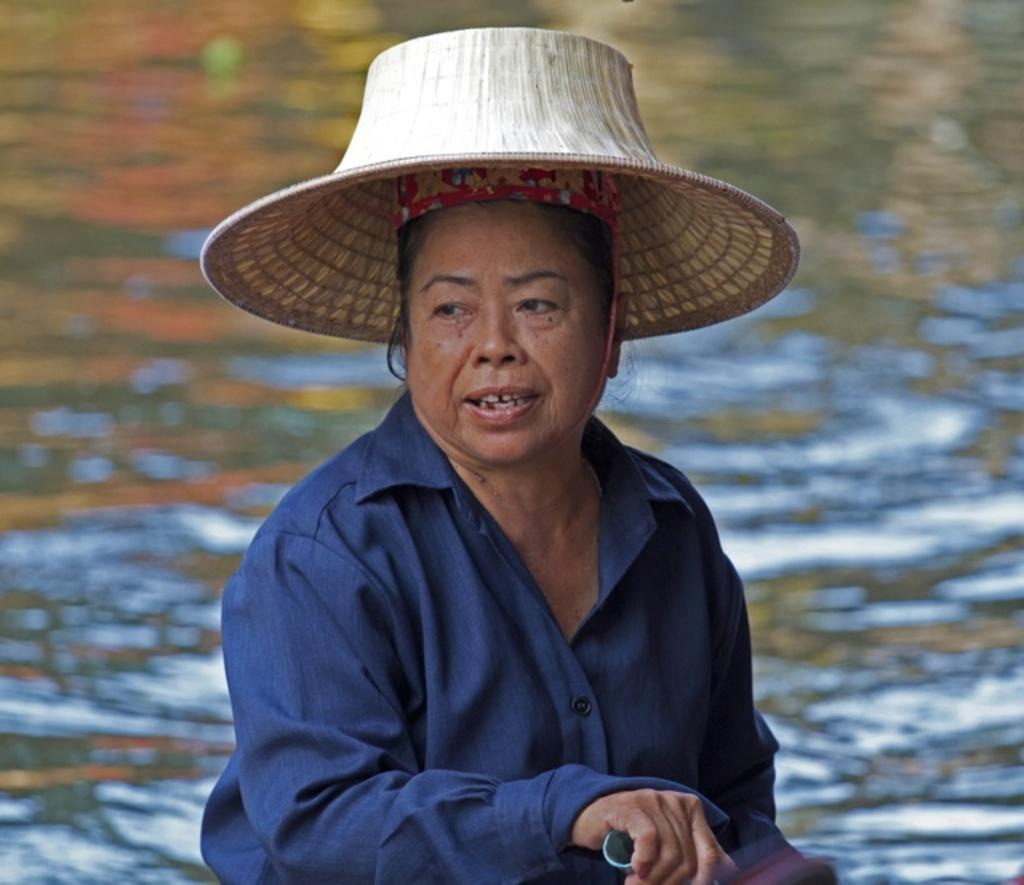Who is the main subject in the image? There is a lady in the center of the image. What is the lady wearing on her head? The lady is wearing a hat. What is the lady holding in her hand? The lady is holding an object. What can be seen in the background of the image? There is water visible in the background of the image. What type of eggnog can be seen in the lady's hand in the image? There is no eggnog present in the image; the lady is holding an object. Can you hear the lady whistling in the image? There is no indication of sound in the image, so it cannot be determined if the lady is whistling. 